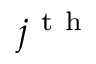Convert formula to latex. <formula><loc_0><loc_0><loc_500><loc_500>j ^ { t h }</formula> 